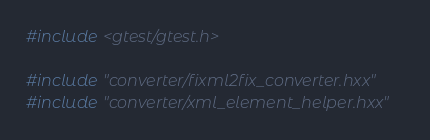Convert code to text. <code><loc_0><loc_0><loc_500><loc_500><_C++_>#include <gtest/gtest.h>

#include "converter/fixml2fix_converter.hxx"
#include "converter/xml_element_helper.hxx"</code> 